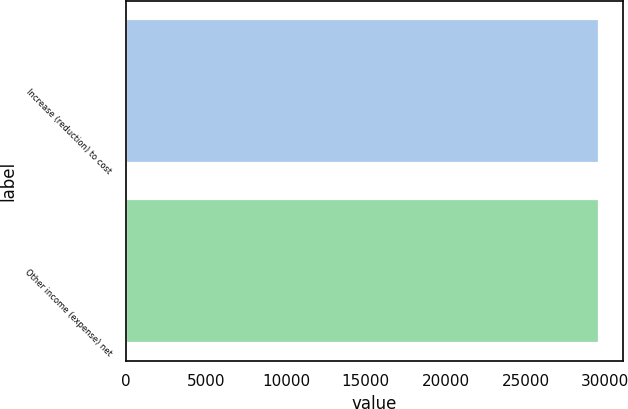Convert chart. <chart><loc_0><loc_0><loc_500><loc_500><bar_chart><fcel>Increase (reduction) to cost<fcel>Other income (expense) net<nl><fcel>29606<fcel>29606.1<nl></chart> 